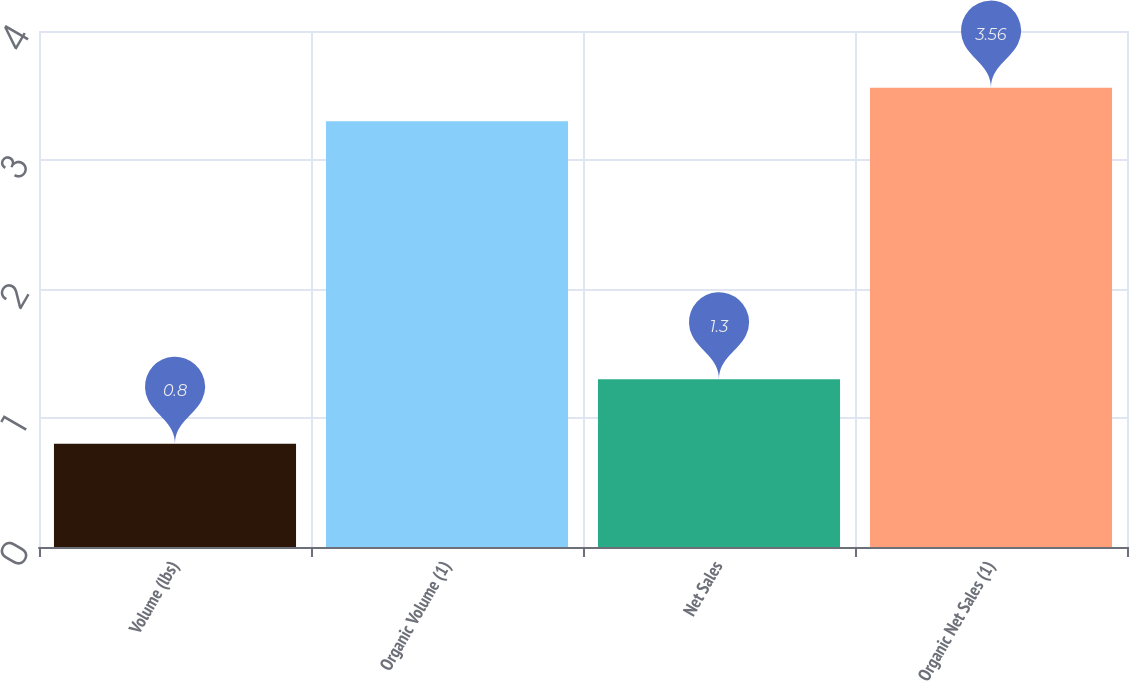Convert chart. <chart><loc_0><loc_0><loc_500><loc_500><bar_chart><fcel>Volume (lbs)<fcel>Organic Volume (1)<fcel>Net Sales<fcel>Organic Net Sales (1)<nl><fcel>0.8<fcel>3.3<fcel>1.3<fcel>3.56<nl></chart> 